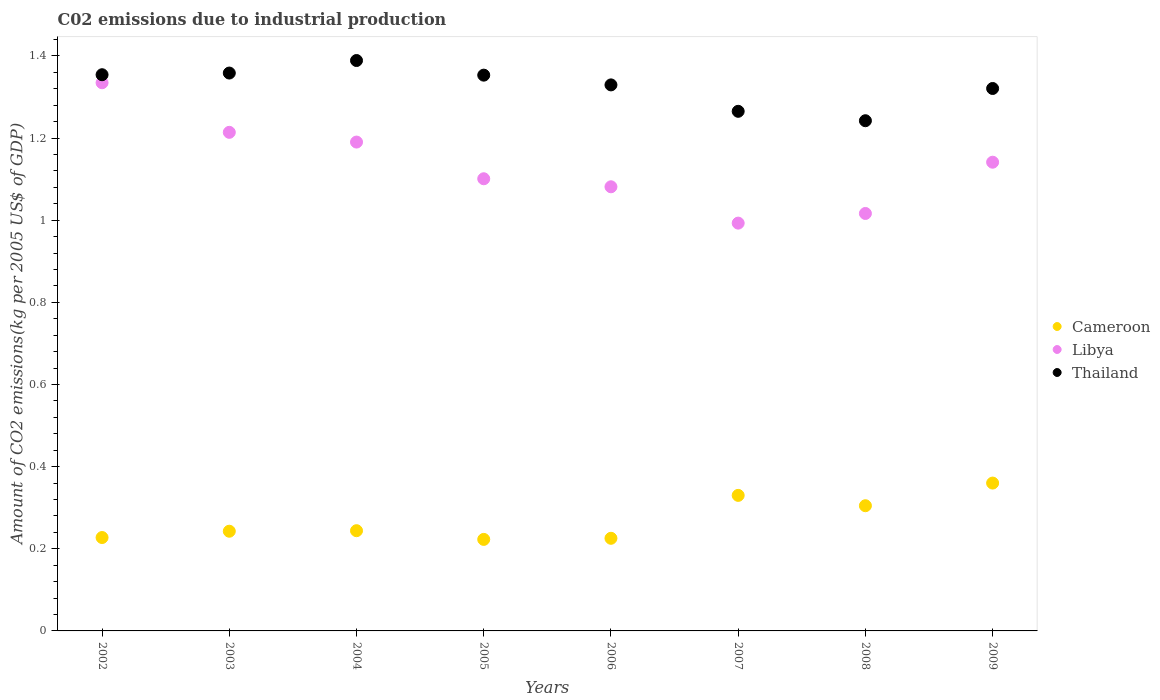How many different coloured dotlines are there?
Your answer should be compact. 3. Is the number of dotlines equal to the number of legend labels?
Provide a succinct answer. Yes. What is the amount of CO2 emitted due to industrial production in Cameroon in 2006?
Make the answer very short. 0.23. Across all years, what is the maximum amount of CO2 emitted due to industrial production in Thailand?
Offer a terse response. 1.39. Across all years, what is the minimum amount of CO2 emitted due to industrial production in Thailand?
Your answer should be very brief. 1.24. In which year was the amount of CO2 emitted due to industrial production in Libya maximum?
Keep it short and to the point. 2002. In which year was the amount of CO2 emitted due to industrial production in Libya minimum?
Your response must be concise. 2007. What is the total amount of CO2 emitted due to industrial production in Libya in the graph?
Your answer should be compact. 9.07. What is the difference between the amount of CO2 emitted due to industrial production in Libya in 2005 and that in 2006?
Your answer should be compact. 0.02. What is the difference between the amount of CO2 emitted due to industrial production in Libya in 2004 and the amount of CO2 emitted due to industrial production in Cameroon in 2003?
Give a very brief answer. 0.95. What is the average amount of CO2 emitted due to industrial production in Libya per year?
Provide a succinct answer. 1.13. In the year 2007, what is the difference between the amount of CO2 emitted due to industrial production in Libya and amount of CO2 emitted due to industrial production in Cameroon?
Your response must be concise. 0.66. What is the ratio of the amount of CO2 emitted due to industrial production in Libya in 2008 to that in 2009?
Keep it short and to the point. 0.89. What is the difference between the highest and the second highest amount of CO2 emitted due to industrial production in Thailand?
Your answer should be very brief. 0.03. What is the difference between the highest and the lowest amount of CO2 emitted due to industrial production in Thailand?
Make the answer very short. 0.15. In how many years, is the amount of CO2 emitted due to industrial production in Thailand greater than the average amount of CO2 emitted due to industrial production in Thailand taken over all years?
Make the answer very short. 5. Does the amount of CO2 emitted due to industrial production in Libya monotonically increase over the years?
Provide a succinct answer. No. Is the amount of CO2 emitted due to industrial production in Libya strictly less than the amount of CO2 emitted due to industrial production in Thailand over the years?
Provide a succinct answer. Yes. How many years are there in the graph?
Ensure brevity in your answer.  8. What is the difference between two consecutive major ticks on the Y-axis?
Give a very brief answer. 0.2. Does the graph contain grids?
Ensure brevity in your answer.  No. Where does the legend appear in the graph?
Provide a short and direct response. Center right. How are the legend labels stacked?
Offer a terse response. Vertical. What is the title of the graph?
Offer a very short reply. C02 emissions due to industrial production. What is the label or title of the Y-axis?
Your answer should be compact. Amount of CO2 emissions(kg per 2005 US$ of GDP). What is the Amount of CO2 emissions(kg per 2005 US$ of GDP) of Cameroon in 2002?
Give a very brief answer. 0.23. What is the Amount of CO2 emissions(kg per 2005 US$ of GDP) of Libya in 2002?
Offer a terse response. 1.33. What is the Amount of CO2 emissions(kg per 2005 US$ of GDP) in Thailand in 2002?
Your answer should be compact. 1.35. What is the Amount of CO2 emissions(kg per 2005 US$ of GDP) in Cameroon in 2003?
Provide a short and direct response. 0.24. What is the Amount of CO2 emissions(kg per 2005 US$ of GDP) of Libya in 2003?
Provide a short and direct response. 1.21. What is the Amount of CO2 emissions(kg per 2005 US$ of GDP) of Thailand in 2003?
Offer a very short reply. 1.36. What is the Amount of CO2 emissions(kg per 2005 US$ of GDP) in Cameroon in 2004?
Offer a very short reply. 0.24. What is the Amount of CO2 emissions(kg per 2005 US$ of GDP) of Libya in 2004?
Offer a terse response. 1.19. What is the Amount of CO2 emissions(kg per 2005 US$ of GDP) in Thailand in 2004?
Your response must be concise. 1.39. What is the Amount of CO2 emissions(kg per 2005 US$ of GDP) in Cameroon in 2005?
Offer a very short reply. 0.22. What is the Amount of CO2 emissions(kg per 2005 US$ of GDP) of Libya in 2005?
Keep it short and to the point. 1.1. What is the Amount of CO2 emissions(kg per 2005 US$ of GDP) of Thailand in 2005?
Your answer should be compact. 1.35. What is the Amount of CO2 emissions(kg per 2005 US$ of GDP) of Cameroon in 2006?
Ensure brevity in your answer.  0.23. What is the Amount of CO2 emissions(kg per 2005 US$ of GDP) in Libya in 2006?
Your answer should be very brief. 1.08. What is the Amount of CO2 emissions(kg per 2005 US$ of GDP) in Thailand in 2006?
Give a very brief answer. 1.33. What is the Amount of CO2 emissions(kg per 2005 US$ of GDP) of Cameroon in 2007?
Ensure brevity in your answer.  0.33. What is the Amount of CO2 emissions(kg per 2005 US$ of GDP) in Libya in 2007?
Offer a terse response. 0.99. What is the Amount of CO2 emissions(kg per 2005 US$ of GDP) in Thailand in 2007?
Ensure brevity in your answer.  1.27. What is the Amount of CO2 emissions(kg per 2005 US$ of GDP) of Cameroon in 2008?
Provide a succinct answer. 0.3. What is the Amount of CO2 emissions(kg per 2005 US$ of GDP) of Libya in 2008?
Offer a very short reply. 1.02. What is the Amount of CO2 emissions(kg per 2005 US$ of GDP) in Thailand in 2008?
Offer a terse response. 1.24. What is the Amount of CO2 emissions(kg per 2005 US$ of GDP) of Cameroon in 2009?
Your answer should be compact. 0.36. What is the Amount of CO2 emissions(kg per 2005 US$ of GDP) in Libya in 2009?
Make the answer very short. 1.14. What is the Amount of CO2 emissions(kg per 2005 US$ of GDP) in Thailand in 2009?
Make the answer very short. 1.32. Across all years, what is the maximum Amount of CO2 emissions(kg per 2005 US$ of GDP) in Cameroon?
Your response must be concise. 0.36. Across all years, what is the maximum Amount of CO2 emissions(kg per 2005 US$ of GDP) in Libya?
Your answer should be compact. 1.33. Across all years, what is the maximum Amount of CO2 emissions(kg per 2005 US$ of GDP) in Thailand?
Provide a succinct answer. 1.39. Across all years, what is the minimum Amount of CO2 emissions(kg per 2005 US$ of GDP) in Cameroon?
Provide a short and direct response. 0.22. Across all years, what is the minimum Amount of CO2 emissions(kg per 2005 US$ of GDP) of Libya?
Your response must be concise. 0.99. Across all years, what is the minimum Amount of CO2 emissions(kg per 2005 US$ of GDP) of Thailand?
Give a very brief answer. 1.24. What is the total Amount of CO2 emissions(kg per 2005 US$ of GDP) in Cameroon in the graph?
Your response must be concise. 2.16. What is the total Amount of CO2 emissions(kg per 2005 US$ of GDP) of Libya in the graph?
Your response must be concise. 9.07. What is the total Amount of CO2 emissions(kg per 2005 US$ of GDP) of Thailand in the graph?
Your answer should be very brief. 10.61. What is the difference between the Amount of CO2 emissions(kg per 2005 US$ of GDP) of Cameroon in 2002 and that in 2003?
Offer a very short reply. -0.02. What is the difference between the Amount of CO2 emissions(kg per 2005 US$ of GDP) of Libya in 2002 and that in 2003?
Ensure brevity in your answer.  0.12. What is the difference between the Amount of CO2 emissions(kg per 2005 US$ of GDP) in Thailand in 2002 and that in 2003?
Make the answer very short. -0. What is the difference between the Amount of CO2 emissions(kg per 2005 US$ of GDP) of Cameroon in 2002 and that in 2004?
Make the answer very short. -0.02. What is the difference between the Amount of CO2 emissions(kg per 2005 US$ of GDP) of Libya in 2002 and that in 2004?
Offer a very short reply. 0.14. What is the difference between the Amount of CO2 emissions(kg per 2005 US$ of GDP) in Thailand in 2002 and that in 2004?
Offer a very short reply. -0.03. What is the difference between the Amount of CO2 emissions(kg per 2005 US$ of GDP) of Cameroon in 2002 and that in 2005?
Ensure brevity in your answer.  0. What is the difference between the Amount of CO2 emissions(kg per 2005 US$ of GDP) in Libya in 2002 and that in 2005?
Keep it short and to the point. 0.23. What is the difference between the Amount of CO2 emissions(kg per 2005 US$ of GDP) of Thailand in 2002 and that in 2005?
Your answer should be compact. 0. What is the difference between the Amount of CO2 emissions(kg per 2005 US$ of GDP) in Cameroon in 2002 and that in 2006?
Offer a very short reply. 0. What is the difference between the Amount of CO2 emissions(kg per 2005 US$ of GDP) in Libya in 2002 and that in 2006?
Make the answer very short. 0.25. What is the difference between the Amount of CO2 emissions(kg per 2005 US$ of GDP) of Thailand in 2002 and that in 2006?
Provide a succinct answer. 0.02. What is the difference between the Amount of CO2 emissions(kg per 2005 US$ of GDP) in Cameroon in 2002 and that in 2007?
Your answer should be compact. -0.1. What is the difference between the Amount of CO2 emissions(kg per 2005 US$ of GDP) in Libya in 2002 and that in 2007?
Ensure brevity in your answer.  0.34. What is the difference between the Amount of CO2 emissions(kg per 2005 US$ of GDP) in Thailand in 2002 and that in 2007?
Your response must be concise. 0.09. What is the difference between the Amount of CO2 emissions(kg per 2005 US$ of GDP) of Cameroon in 2002 and that in 2008?
Provide a succinct answer. -0.08. What is the difference between the Amount of CO2 emissions(kg per 2005 US$ of GDP) in Libya in 2002 and that in 2008?
Give a very brief answer. 0.32. What is the difference between the Amount of CO2 emissions(kg per 2005 US$ of GDP) of Thailand in 2002 and that in 2008?
Keep it short and to the point. 0.11. What is the difference between the Amount of CO2 emissions(kg per 2005 US$ of GDP) in Cameroon in 2002 and that in 2009?
Provide a short and direct response. -0.13. What is the difference between the Amount of CO2 emissions(kg per 2005 US$ of GDP) of Libya in 2002 and that in 2009?
Provide a succinct answer. 0.19. What is the difference between the Amount of CO2 emissions(kg per 2005 US$ of GDP) of Thailand in 2002 and that in 2009?
Your answer should be very brief. 0.03. What is the difference between the Amount of CO2 emissions(kg per 2005 US$ of GDP) of Cameroon in 2003 and that in 2004?
Keep it short and to the point. -0. What is the difference between the Amount of CO2 emissions(kg per 2005 US$ of GDP) of Libya in 2003 and that in 2004?
Offer a terse response. 0.02. What is the difference between the Amount of CO2 emissions(kg per 2005 US$ of GDP) in Thailand in 2003 and that in 2004?
Provide a succinct answer. -0.03. What is the difference between the Amount of CO2 emissions(kg per 2005 US$ of GDP) of Cameroon in 2003 and that in 2005?
Keep it short and to the point. 0.02. What is the difference between the Amount of CO2 emissions(kg per 2005 US$ of GDP) in Libya in 2003 and that in 2005?
Your answer should be compact. 0.11. What is the difference between the Amount of CO2 emissions(kg per 2005 US$ of GDP) in Thailand in 2003 and that in 2005?
Your answer should be compact. 0.01. What is the difference between the Amount of CO2 emissions(kg per 2005 US$ of GDP) in Cameroon in 2003 and that in 2006?
Your answer should be very brief. 0.02. What is the difference between the Amount of CO2 emissions(kg per 2005 US$ of GDP) in Libya in 2003 and that in 2006?
Your answer should be compact. 0.13. What is the difference between the Amount of CO2 emissions(kg per 2005 US$ of GDP) of Thailand in 2003 and that in 2006?
Ensure brevity in your answer.  0.03. What is the difference between the Amount of CO2 emissions(kg per 2005 US$ of GDP) in Cameroon in 2003 and that in 2007?
Your answer should be compact. -0.09. What is the difference between the Amount of CO2 emissions(kg per 2005 US$ of GDP) of Libya in 2003 and that in 2007?
Your answer should be compact. 0.22. What is the difference between the Amount of CO2 emissions(kg per 2005 US$ of GDP) of Thailand in 2003 and that in 2007?
Provide a succinct answer. 0.09. What is the difference between the Amount of CO2 emissions(kg per 2005 US$ of GDP) of Cameroon in 2003 and that in 2008?
Offer a terse response. -0.06. What is the difference between the Amount of CO2 emissions(kg per 2005 US$ of GDP) in Libya in 2003 and that in 2008?
Ensure brevity in your answer.  0.2. What is the difference between the Amount of CO2 emissions(kg per 2005 US$ of GDP) of Thailand in 2003 and that in 2008?
Your answer should be very brief. 0.12. What is the difference between the Amount of CO2 emissions(kg per 2005 US$ of GDP) in Cameroon in 2003 and that in 2009?
Make the answer very short. -0.12. What is the difference between the Amount of CO2 emissions(kg per 2005 US$ of GDP) in Libya in 2003 and that in 2009?
Keep it short and to the point. 0.07. What is the difference between the Amount of CO2 emissions(kg per 2005 US$ of GDP) in Thailand in 2003 and that in 2009?
Provide a succinct answer. 0.04. What is the difference between the Amount of CO2 emissions(kg per 2005 US$ of GDP) in Cameroon in 2004 and that in 2005?
Your answer should be compact. 0.02. What is the difference between the Amount of CO2 emissions(kg per 2005 US$ of GDP) in Libya in 2004 and that in 2005?
Offer a very short reply. 0.09. What is the difference between the Amount of CO2 emissions(kg per 2005 US$ of GDP) in Thailand in 2004 and that in 2005?
Your answer should be compact. 0.04. What is the difference between the Amount of CO2 emissions(kg per 2005 US$ of GDP) in Cameroon in 2004 and that in 2006?
Make the answer very short. 0.02. What is the difference between the Amount of CO2 emissions(kg per 2005 US$ of GDP) of Libya in 2004 and that in 2006?
Your response must be concise. 0.11. What is the difference between the Amount of CO2 emissions(kg per 2005 US$ of GDP) in Thailand in 2004 and that in 2006?
Your answer should be very brief. 0.06. What is the difference between the Amount of CO2 emissions(kg per 2005 US$ of GDP) in Cameroon in 2004 and that in 2007?
Your response must be concise. -0.09. What is the difference between the Amount of CO2 emissions(kg per 2005 US$ of GDP) of Libya in 2004 and that in 2007?
Offer a terse response. 0.2. What is the difference between the Amount of CO2 emissions(kg per 2005 US$ of GDP) in Thailand in 2004 and that in 2007?
Your answer should be very brief. 0.12. What is the difference between the Amount of CO2 emissions(kg per 2005 US$ of GDP) of Cameroon in 2004 and that in 2008?
Make the answer very short. -0.06. What is the difference between the Amount of CO2 emissions(kg per 2005 US$ of GDP) of Libya in 2004 and that in 2008?
Provide a succinct answer. 0.17. What is the difference between the Amount of CO2 emissions(kg per 2005 US$ of GDP) of Thailand in 2004 and that in 2008?
Your answer should be compact. 0.15. What is the difference between the Amount of CO2 emissions(kg per 2005 US$ of GDP) of Cameroon in 2004 and that in 2009?
Make the answer very short. -0.12. What is the difference between the Amount of CO2 emissions(kg per 2005 US$ of GDP) in Libya in 2004 and that in 2009?
Provide a succinct answer. 0.05. What is the difference between the Amount of CO2 emissions(kg per 2005 US$ of GDP) in Thailand in 2004 and that in 2009?
Provide a succinct answer. 0.07. What is the difference between the Amount of CO2 emissions(kg per 2005 US$ of GDP) in Cameroon in 2005 and that in 2006?
Make the answer very short. -0. What is the difference between the Amount of CO2 emissions(kg per 2005 US$ of GDP) of Libya in 2005 and that in 2006?
Offer a very short reply. 0.02. What is the difference between the Amount of CO2 emissions(kg per 2005 US$ of GDP) of Thailand in 2005 and that in 2006?
Give a very brief answer. 0.02. What is the difference between the Amount of CO2 emissions(kg per 2005 US$ of GDP) of Cameroon in 2005 and that in 2007?
Ensure brevity in your answer.  -0.11. What is the difference between the Amount of CO2 emissions(kg per 2005 US$ of GDP) in Libya in 2005 and that in 2007?
Keep it short and to the point. 0.11. What is the difference between the Amount of CO2 emissions(kg per 2005 US$ of GDP) in Thailand in 2005 and that in 2007?
Make the answer very short. 0.09. What is the difference between the Amount of CO2 emissions(kg per 2005 US$ of GDP) of Cameroon in 2005 and that in 2008?
Your response must be concise. -0.08. What is the difference between the Amount of CO2 emissions(kg per 2005 US$ of GDP) of Libya in 2005 and that in 2008?
Your answer should be compact. 0.08. What is the difference between the Amount of CO2 emissions(kg per 2005 US$ of GDP) of Thailand in 2005 and that in 2008?
Give a very brief answer. 0.11. What is the difference between the Amount of CO2 emissions(kg per 2005 US$ of GDP) of Cameroon in 2005 and that in 2009?
Your answer should be very brief. -0.14. What is the difference between the Amount of CO2 emissions(kg per 2005 US$ of GDP) in Libya in 2005 and that in 2009?
Keep it short and to the point. -0.04. What is the difference between the Amount of CO2 emissions(kg per 2005 US$ of GDP) of Thailand in 2005 and that in 2009?
Provide a short and direct response. 0.03. What is the difference between the Amount of CO2 emissions(kg per 2005 US$ of GDP) of Cameroon in 2006 and that in 2007?
Ensure brevity in your answer.  -0.1. What is the difference between the Amount of CO2 emissions(kg per 2005 US$ of GDP) in Libya in 2006 and that in 2007?
Your answer should be compact. 0.09. What is the difference between the Amount of CO2 emissions(kg per 2005 US$ of GDP) in Thailand in 2006 and that in 2007?
Offer a terse response. 0.06. What is the difference between the Amount of CO2 emissions(kg per 2005 US$ of GDP) in Cameroon in 2006 and that in 2008?
Your answer should be compact. -0.08. What is the difference between the Amount of CO2 emissions(kg per 2005 US$ of GDP) in Libya in 2006 and that in 2008?
Keep it short and to the point. 0.07. What is the difference between the Amount of CO2 emissions(kg per 2005 US$ of GDP) in Thailand in 2006 and that in 2008?
Provide a succinct answer. 0.09. What is the difference between the Amount of CO2 emissions(kg per 2005 US$ of GDP) of Cameroon in 2006 and that in 2009?
Your response must be concise. -0.13. What is the difference between the Amount of CO2 emissions(kg per 2005 US$ of GDP) in Libya in 2006 and that in 2009?
Offer a very short reply. -0.06. What is the difference between the Amount of CO2 emissions(kg per 2005 US$ of GDP) of Thailand in 2006 and that in 2009?
Give a very brief answer. 0.01. What is the difference between the Amount of CO2 emissions(kg per 2005 US$ of GDP) of Cameroon in 2007 and that in 2008?
Your answer should be compact. 0.03. What is the difference between the Amount of CO2 emissions(kg per 2005 US$ of GDP) of Libya in 2007 and that in 2008?
Offer a terse response. -0.02. What is the difference between the Amount of CO2 emissions(kg per 2005 US$ of GDP) of Thailand in 2007 and that in 2008?
Offer a terse response. 0.02. What is the difference between the Amount of CO2 emissions(kg per 2005 US$ of GDP) of Cameroon in 2007 and that in 2009?
Provide a short and direct response. -0.03. What is the difference between the Amount of CO2 emissions(kg per 2005 US$ of GDP) of Libya in 2007 and that in 2009?
Your response must be concise. -0.15. What is the difference between the Amount of CO2 emissions(kg per 2005 US$ of GDP) in Thailand in 2007 and that in 2009?
Your response must be concise. -0.06. What is the difference between the Amount of CO2 emissions(kg per 2005 US$ of GDP) in Cameroon in 2008 and that in 2009?
Ensure brevity in your answer.  -0.06. What is the difference between the Amount of CO2 emissions(kg per 2005 US$ of GDP) in Libya in 2008 and that in 2009?
Ensure brevity in your answer.  -0.12. What is the difference between the Amount of CO2 emissions(kg per 2005 US$ of GDP) in Thailand in 2008 and that in 2009?
Your answer should be compact. -0.08. What is the difference between the Amount of CO2 emissions(kg per 2005 US$ of GDP) in Cameroon in 2002 and the Amount of CO2 emissions(kg per 2005 US$ of GDP) in Libya in 2003?
Offer a very short reply. -0.99. What is the difference between the Amount of CO2 emissions(kg per 2005 US$ of GDP) of Cameroon in 2002 and the Amount of CO2 emissions(kg per 2005 US$ of GDP) of Thailand in 2003?
Keep it short and to the point. -1.13. What is the difference between the Amount of CO2 emissions(kg per 2005 US$ of GDP) of Libya in 2002 and the Amount of CO2 emissions(kg per 2005 US$ of GDP) of Thailand in 2003?
Provide a short and direct response. -0.02. What is the difference between the Amount of CO2 emissions(kg per 2005 US$ of GDP) in Cameroon in 2002 and the Amount of CO2 emissions(kg per 2005 US$ of GDP) in Libya in 2004?
Offer a very short reply. -0.96. What is the difference between the Amount of CO2 emissions(kg per 2005 US$ of GDP) of Cameroon in 2002 and the Amount of CO2 emissions(kg per 2005 US$ of GDP) of Thailand in 2004?
Provide a succinct answer. -1.16. What is the difference between the Amount of CO2 emissions(kg per 2005 US$ of GDP) of Libya in 2002 and the Amount of CO2 emissions(kg per 2005 US$ of GDP) of Thailand in 2004?
Your answer should be compact. -0.05. What is the difference between the Amount of CO2 emissions(kg per 2005 US$ of GDP) of Cameroon in 2002 and the Amount of CO2 emissions(kg per 2005 US$ of GDP) of Libya in 2005?
Offer a terse response. -0.87. What is the difference between the Amount of CO2 emissions(kg per 2005 US$ of GDP) in Cameroon in 2002 and the Amount of CO2 emissions(kg per 2005 US$ of GDP) in Thailand in 2005?
Offer a very short reply. -1.13. What is the difference between the Amount of CO2 emissions(kg per 2005 US$ of GDP) in Libya in 2002 and the Amount of CO2 emissions(kg per 2005 US$ of GDP) in Thailand in 2005?
Provide a short and direct response. -0.02. What is the difference between the Amount of CO2 emissions(kg per 2005 US$ of GDP) of Cameroon in 2002 and the Amount of CO2 emissions(kg per 2005 US$ of GDP) of Libya in 2006?
Your response must be concise. -0.85. What is the difference between the Amount of CO2 emissions(kg per 2005 US$ of GDP) of Cameroon in 2002 and the Amount of CO2 emissions(kg per 2005 US$ of GDP) of Thailand in 2006?
Your answer should be very brief. -1.1. What is the difference between the Amount of CO2 emissions(kg per 2005 US$ of GDP) of Libya in 2002 and the Amount of CO2 emissions(kg per 2005 US$ of GDP) of Thailand in 2006?
Offer a very short reply. 0.01. What is the difference between the Amount of CO2 emissions(kg per 2005 US$ of GDP) in Cameroon in 2002 and the Amount of CO2 emissions(kg per 2005 US$ of GDP) in Libya in 2007?
Ensure brevity in your answer.  -0.77. What is the difference between the Amount of CO2 emissions(kg per 2005 US$ of GDP) in Cameroon in 2002 and the Amount of CO2 emissions(kg per 2005 US$ of GDP) in Thailand in 2007?
Provide a short and direct response. -1.04. What is the difference between the Amount of CO2 emissions(kg per 2005 US$ of GDP) of Libya in 2002 and the Amount of CO2 emissions(kg per 2005 US$ of GDP) of Thailand in 2007?
Your response must be concise. 0.07. What is the difference between the Amount of CO2 emissions(kg per 2005 US$ of GDP) of Cameroon in 2002 and the Amount of CO2 emissions(kg per 2005 US$ of GDP) of Libya in 2008?
Provide a short and direct response. -0.79. What is the difference between the Amount of CO2 emissions(kg per 2005 US$ of GDP) of Cameroon in 2002 and the Amount of CO2 emissions(kg per 2005 US$ of GDP) of Thailand in 2008?
Keep it short and to the point. -1.01. What is the difference between the Amount of CO2 emissions(kg per 2005 US$ of GDP) of Libya in 2002 and the Amount of CO2 emissions(kg per 2005 US$ of GDP) of Thailand in 2008?
Offer a very short reply. 0.09. What is the difference between the Amount of CO2 emissions(kg per 2005 US$ of GDP) in Cameroon in 2002 and the Amount of CO2 emissions(kg per 2005 US$ of GDP) in Libya in 2009?
Your answer should be compact. -0.91. What is the difference between the Amount of CO2 emissions(kg per 2005 US$ of GDP) in Cameroon in 2002 and the Amount of CO2 emissions(kg per 2005 US$ of GDP) in Thailand in 2009?
Ensure brevity in your answer.  -1.09. What is the difference between the Amount of CO2 emissions(kg per 2005 US$ of GDP) in Libya in 2002 and the Amount of CO2 emissions(kg per 2005 US$ of GDP) in Thailand in 2009?
Your answer should be compact. 0.01. What is the difference between the Amount of CO2 emissions(kg per 2005 US$ of GDP) in Cameroon in 2003 and the Amount of CO2 emissions(kg per 2005 US$ of GDP) in Libya in 2004?
Keep it short and to the point. -0.95. What is the difference between the Amount of CO2 emissions(kg per 2005 US$ of GDP) of Cameroon in 2003 and the Amount of CO2 emissions(kg per 2005 US$ of GDP) of Thailand in 2004?
Offer a terse response. -1.15. What is the difference between the Amount of CO2 emissions(kg per 2005 US$ of GDP) of Libya in 2003 and the Amount of CO2 emissions(kg per 2005 US$ of GDP) of Thailand in 2004?
Your answer should be very brief. -0.17. What is the difference between the Amount of CO2 emissions(kg per 2005 US$ of GDP) in Cameroon in 2003 and the Amount of CO2 emissions(kg per 2005 US$ of GDP) in Libya in 2005?
Your answer should be very brief. -0.86. What is the difference between the Amount of CO2 emissions(kg per 2005 US$ of GDP) of Cameroon in 2003 and the Amount of CO2 emissions(kg per 2005 US$ of GDP) of Thailand in 2005?
Provide a short and direct response. -1.11. What is the difference between the Amount of CO2 emissions(kg per 2005 US$ of GDP) of Libya in 2003 and the Amount of CO2 emissions(kg per 2005 US$ of GDP) of Thailand in 2005?
Your answer should be very brief. -0.14. What is the difference between the Amount of CO2 emissions(kg per 2005 US$ of GDP) of Cameroon in 2003 and the Amount of CO2 emissions(kg per 2005 US$ of GDP) of Libya in 2006?
Make the answer very short. -0.84. What is the difference between the Amount of CO2 emissions(kg per 2005 US$ of GDP) in Cameroon in 2003 and the Amount of CO2 emissions(kg per 2005 US$ of GDP) in Thailand in 2006?
Make the answer very short. -1.09. What is the difference between the Amount of CO2 emissions(kg per 2005 US$ of GDP) in Libya in 2003 and the Amount of CO2 emissions(kg per 2005 US$ of GDP) in Thailand in 2006?
Your answer should be very brief. -0.12. What is the difference between the Amount of CO2 emissions(kg per 2005 US$ of GDP) in Cameroon in 2003 and the Amount of CO2 emissions(kg per 2005 US$ of GDP) in Libya in 2007?
Offer a terse response. -0.75. What is the difference between the Amount of CO2 emissions(kg per 2005 US$ of GDP) of Cameroon in 2003 and the Amount of CO2 emissions(kg per 2005 US$ of GDP) of Thailand in 2007?
Ensure brevity in your answer.  -1.02. What is the difference between the Amount of CO2 emissions(kg per 2005 US$ of GDP) in Libya in 2003 and the Amount of CO2 emissions(kg per 2005 US$ of GDP) in Thailand in 2007?
Provide a succinct answer. -0.05. What is the difference between the Amount of CO2 emissions(kg per 2005 US$ of GDP) in Cameroon in 2003 and the Amount of CO2 emissions(kg per 2005 US$ of GDP) in Libya in 2008?
Make the answer very short. -0.77. What is the difference between the Amount of CO2 emissions(kg per 2005 US$ of GDP) in Cameroon in 2003 and the Amount of CO2 emissions(kg per 2005 US$ of GDP) in Thailand in 2008?
Provide a short and direct response. -1. What is the difference between the Amount of CO2 emissions(kg per 2005 US$ of GDP) of Libya in 2003 and the Amount of CO2 emissions(kg per 2005 US$ of GDP) of Thailand in 2008?
Make the answer very short. -0.03. What is the difference between the Amount of CO2 emissions(kg per 2005 US$ of GDP) of Cameroon in 2003 and the Amount of CO2 emissions(kg per 2005 US$ of GDP) of Libya in 2009?
Offer a terse response. -0.9. What is the difference between the Amount of CO2 emissions(kg per 2005 US$ of GDP) in Cameroon in 2003 and the Amount of CO2 emissions(kg per 2005 US$ of GDP) in Thailand in 2009?
Your answer should be compact. -1.08. What is the difference between the Amount of CO2 emissions(kg per 2005 US$ of GDP) in Libya in 2003 and the Amount of CO2 emissions(kg per 2005 US$ of GDP) in Thailand in 2009?
Keep it short and to the point. -0.11. What is the difference between the Amount of CO2 emissions(kg per 2005 US$ of GDP) of Cameroon in 2004 and the Amount of CO2 emissions(kg per 2005 US$ of GDP) of Libya in 2005?
Your answer should be very brief. -0.86. What is the difference between the Amount of CO2 emissions(kg per 2005 US$ of GDP) of Cameroon in 2004 and the Amount of CO2 emissions(kg per 2005 US$ of GDP) of Thailand in 2005?
Offer a very short reply. -1.11. What is the difference between the Amount of CO2 emissions(kg per 2005 US$ of GDP) in Libya in 2004 and the Amount of CO2 emissions(kg per 2005 US$ of GDP) in Thailand in 2005?
Ensure brevity in your answer.  -0.16. What is the difference between the Amount of CO2 emissions(kg per 2005 US$ of GDP) of Cameroon in 2004 and the Amount of CO2 emissions(kg per 2005 US$ of GDP) of Libya in 2006?
Your answer should be compact. -0.84. What is the difference between the Amount of CO2 emissions(kg per 2005 US$ of GDP) of Cameroon in 2004 and the Amount of CO2 emissions(kg per 2005 US$ of GDP) of Thailand in 2006?
Your answer should be very brief. -1.09. What is the difference between the Amount of CO2 emissions(kg per 2005 US$ of GDP) of Libya in 2004 and the Amount of CO2 emissions(kg per 2005 US$ of GDP) of Thailand in 2006?
Give a very brief answer. -0.14. What is the difference between the Amount of CO2 emissions(kg per 2005 US$ of GDP) in Cameroon in 2004 and the Amount of CO2 emissions(kg per 2005 US$ of GDP) in Libya in 2007?
Your response must be concise. -0.75. What is the difference between the Amount of CO2 emissions(kg per 2005 US$ of GDP) of Cameroon in 2004 and the Amount of CO2 emissions(kg per 2005 US$ of GDP) of Thailand in 2007?
Keep it short and to the point. -1.02. What is the difference between the Amount of CO2 emissions(kg per 2005 US$ of GDP) in Libya in 2004 and the Amount of CO2 emissions(kg per 2005 US$ of GDP) in Thailand in 2007?
Your answer should be very brief. -0.07. What is the difference between the Amount of CO2 emissions(kg per 2005 US$ of GDP) of Cameroon in 2004 and the Amount of CO2 emissions(kg per 2005 US$ of GDP) of Libya in 2008?
Offer a very short reply. -0.77. What is the difference between the Amount of CO2 emissions(kg per 2005 US$ of GDP) of Cameroon in 2004 and the Amount of CO2 emissions(kg per 2005 US$ of GDP) of Thailand in 2008?
Provide a succinct answer. -1. What is the difference between the Amount of CO2 emissions(kg per 2005 US$ of GDP) in Libya in 2004 and the Amount of CO2 emissions(kg per 2005 US$ of GDP) in Thailand in 2008?
Give a very brief answer. -0.05. What is the difference between the Amount of CO2 emissions(kg per 2005 US$ of GDP) in Cameroon in 2004 and the Amount of CO2 emissions(kg per 2005 US$ of GDP) in Libya in 2009?
Your answer should be very brief. -0.9. What is the difference between the Amount of CO2 emissions(kg per 2005 US$ of GDP) of Cameroon in 2004 and the Amount of CO2 emissions(kg per 2005 US$ of GDP) of Thailand in 2009?
Provide a succinct answer. -1.08. What is the difference between the Amount of CO2 emissions(kg per 2005 US$ of GDP) in Libya in 2004 and the Amount of CO2 emissions(kg per 2005 US$ of GDP) in Thailand in 2009?
Offer a very short reply. -0.13. What is the difference between the Amount of CO2 emissions(kg per 2005 US$ of GDP) of Cameroon in 2005 and the Amount of CO2 emissions(kg per 2005 US$ of GDP) of Libya in 2006?
Give a very brief answer. -0.86. What is the difference between the Amount of CO2 emissions(kg per 2005 US$ of GDP) in Cameroon in 2005 and the Amount of CO2 emissions(kg per 2005 US$ of GDP) in Thailand in 2006?
Ensure brevity in your answer.  -1.11. What is the difference between the Amount of CO2 emissions(kg per 2005 US$ of GDP) of Libya in 2005 and the Amount of CO2 emissions(kg per 2005 US$ of GDP) of Thailand in 2006?
Offer a very short reply. -0.23. What is the difference between the Amount of CO2 emissions(kg per 2005 US$ of GDP) of Cameroon in 2005 and the Amount of CO2 emissions(kg per 2005 US$ of GDP) of Libya in 2007?
Give a very brief answer. -0.77. What is the difference between the Amount of CO2 emissions(kg per 2005 US$ of GDP) in Cameroon in 2005 and the Amount of CO2 emissions(kg per 2005 US$ of GDP) in Thailand in 2007?
Your answer should be compact. -1.04. What is the difference between the Amount of CO2 emissions(kg per 2005 US$ of GDP) in Libya in 2005 and the Amount of CO2 emissions(kg per 2005 US$ of GDP) in Thailand in 2007?
Make the answer very short. -0.16. What is the difference between the Amount of CO2 emissions(kg per 2005 US$ of GDP) of Cameroon in 2005 and the Amount of CO2 emissions(kg per 2005 US$ of GDP) of Libya in 2008?
Make the answer very short. -0.79. What is the difference between the Amount of CO2 emissions(kg per 2005 US$ of GDP) in Cameroon in 2005 and the Amount of CO2 emissions(kg per 2005 US$ of GDP) in Thailand in 2008?
Keep it short and to the point. -1.02. What is the difference between the Amount of CO2 emissions(kg per 2005 US$ of GDP) in Libya in 2005 and the Amount of CO2 emissions(kg per 2005 US$ of GDP) in Thailand in 2008?
Make the answer very short. -0.14. What is the difference between the Amount of CO2 emissions(kg per 2005 US$ of GDP) in Cameroon in 2005 and the Amount of CO2 emissions(kg per 2005 US$ of GDP) in Libya in 2009?
Your response must be concise. -0.92. What is the difference between the Amount of CO2 emissions(kg per 2005 US$ of GDP) of Cameroon in 2005 and the Amount of CO2 emissions(kg per 2005 US$ of GDP) of Thailand in 2009?
Give a very brief answer. -1.1. What is the difference between the Amount of CO2 emissions(kg per 2005 US$ of GDP) of Libya in 2005 and the Amount of CO2 emissions(kg per 2005 US$ of GDP) of Thailand in 2009?
Give a very brief answer. -0.22. What is the difference between the Amount of CO2 emissions(kg per 2005 US$ of GDP) in Cameroon in 2006 and the Amount of CO2 emissions(kg per 2005 US$ of GDP) in Libya in 2007?
Offer a terse response. -0.77. What is the difference between the Amount of CO2 emissions(kg per 2005 US$ of GDP) of Cameroon in 2006 and the Amount of CO2 emissions(kg per 2005 US$ of GDP) of Thailand in 2007?
Give a very brief answer. -1.04. What is the difference between the Amount of CO2 emissions(kg per 2005 US$ of GDP) of Libya in 2006 and the Amount of CO2 emissions(kg per 2005 US$ of GDP) of Thailand in 2007?
Your answer should be compact. -0.18. What is the difference between the Amount of CO2 emissions(kg per 2005 US$ of GDP) of Cameroon in 2006 and the Amount of CO2 emissions(kg per 2005 US$ of GDP) of Libya in 2008?
Ensure brevity in your answer.  -0.79. What is the difference between the Amount of CO2 emissions(kg per 2005 US$ of GDP) in Cameroon in 2006 and the Amount of CO2 emissions(kg per 2005 US$ of GDP) in Thailand in 2008?
Provide a short and direct response. -1.02. What is the difference between the Amount of CO2 emissions(kg per 2005 US$ of GDP) of Libya in 2006 and the Amount of CO2 emissions(kg per 2005 US$ of GDP) of Thailand in 2008?
Provide a short and direct response. -0.16. What is the difference between the Amount of CO2 emissions(kg per 2005 US$ of GDP) in Cameroon in 2006 and the Amount of CO2 emissions(kg per 2005 US$ of GDP) in Libya in 2009?
Keep it short and to the point. -0.92. What is the difference between the Amount of CO2 emissions(kg per 2005 US$ of GDP) in Cameroon in 2006 and the Amount of CO2 emissions(kg per 2005 US$ of GDP) in Thailand in 2009?
Your response must be concise. -1.1. What is the difference between the Amount of CO2 emissions(kg per 2005 US$ of GDP) of Libya in 2006 and the Amount of CO2 emissions(kg per 2005 US$ of GDP) of Thailand in 2009?
Make the answer very short. -0.24. What is the difference between the Amount of CO2 emissions(kg per 2005 US$ of GDP) of Cameroon in 2007 and the Amount of CO2 emissions(kg per 2005 US$ of GDP) of Libya in 2008?
Offer a terse response. -0.69. What is the difference between the Amount of CO2 emissions(kg per 2005 US$ of GDP) in Cameroon in 2007 and the Amount of CO2 emissions(kg per 2005 US$ of GDP) in Thailand in 2008?
Offer a very short reply. -0.91. What is the difference between the Amount of CO2 emissions(kg per 2005 US$ of GDP) in Libya in 2007 and the Amount of CO2 emissions(kg per 2005 US$ of GDP) in Thailand in 2008?
Keep it short and to the point. -0.25. What is the difference between the Amount of CO2 emissions(kg per 2005 US$ of GDP) in Cameroon in 2007 and the Amount of CO2 emissions(kg per 2005 US$ of GDP) in Libya in 2009?
Provide a short and direct response. -0.81. What is the difference between the Amount of CO2 emissions(kg per 2005 US$ of GDP) in Cameroon in 2007 and the Amount of CO2 emissions(kg per 2005 US$ of GDP) in Thailand in 2009?
Provide a succinct answer. -0.99. What is the difference between the Amount of CO2 emissions(kg per 2005 US$ of GDP) of Libya in 2007 and the Amount of CO2 emissions(kg per 2005 US$ of GDP) of Thailand in 2009?
Give a very brief answer. -0.33. What is the difference between the Amount of CO2 emissions(kg per 2005 US$ of GDP) in Cameroon in 2008 and the Amount of CO2 emissions(kg per 2005 US$ of GDP) in Libya in 2009?
Ensure brevity in your answer.  -0.84. What is the difference between the Amount of CO2 emissions(kg per 2005 US$ of GDP) in Cameroon in 2008 and the Amount of CO2 emissions(kg per 2005 US$ of GDP) in Thailand in 2009?
Make the answer very short. -1.02. What is the difference between the Amount of CO2 emissions(kg per 2005 US$ of GDP) of Libya in 2008 and the Amount of CO2 emissions(kg per 2005 US$ of GDP) of Thailand in 2009?
Your response must be concise. -0.3. What is the average Amount of CO2 emissions(kg per 2005 US$ of GDP) in Cameroon per year?
Ensure brevity in your answer.  0.27. What is the average Amount of CO2 emissions(kg per 2005 US$ of GDP) of Libya per year?
Your answer should be compact. 1.13. What is the average Amount of CO2 emissions(kg per 2005 US$ of GDP) in Thailand per year?
Give a very brief answer. 1.33. In the year 2002, what is the difference between the Amount of CO2 emissions(kg per 2005 US$ of GDP) in Cameroon and Amount of CO2 emissions(kg per 2005 US$ of GDP) in Libya?
Your response must be concise. -1.11. In the year 2002, what is the difference between the Amount of CO2 emissions(kg per 2005 US$ of GDP) of Cameroon and Amount of CO2 emissions(kg per 2005 US$ of GDP) of Thailand?
Your response must be concise. -1.13. In the year 2002, what is the difference between the Amount of CO2 emissions(kg per 2005 US$ of GDP) in Libya and Amount of CO2 emissions(kg per 2005 US$ of GDP) in Thailand?
Offer a very short reply. -0.02. In the year 2003, what is the difference between the Amount of CO2 emissions(kg per 2005 US$ of GDP) of Cameroon and Amount of CO2 emissions(kg per 2005 US$ of GDP) of Libya?
Give a very brief answer. -0.97. In the year 2003, what is the difference between the Amount of CO2 emissions(kg per 2005 US$ of GDP) of Cameroon and Amount of CO2 emissions(kg per 2005 US$ of GDP) of Thailand?
Provide a succinct answer. -1.12. In the year 2003, what is the difference between the Amount of CO2 emissions(kg per 2005 US$ of GDP) in Libya and Amount of CO2 emissions(kg per 2005 US$ of GDP) in Thailand?
Ensure brevity in your answer.  -0.14. In the year 2004, what is the difference between the Amount of CO2 emissions(kg per 2005 US$ of GDP) in Cameroon and Amount of CO2 emissions(kg per 2005 US$ of GDP) in Libya?
Your response must be concise. -0.95. In the year 2004, what is the difference between the Amount of CO2 emissions(kg per 2005 US$ of GDP) of Cameroon and Amount of CO2 emissions(kg per 2005 US$ of GDP) of Thailand?
Your answer should be compact. -1.14. In the year 2004, what is the difference between the Amount of CO2 emissions(kg per 2005 US$ of GDP) of Libya and Amount of CO2 emissions(kg per 2005 US$ of GDP) of Thailand?
Keep it short and to the point. -0.2. In the year 2005, what is the difference between the Amount of CO2 emissions(kg per 2005 US$ of GDP) in Cameroon and Amount of CO2 emissions(kg per 2005 US$ of GDP) in Libya?
Ensure brevity in your answer.  -0.88. In the year 2005, what is the difference between the Amount of CO2 emissions(kg per 2005 US$ of GDP) of Cameroon and Amount of CO2 emissions(kg per 2005 US$ of GDP) of Thailand?
Ensure brevity in your answer.  -1.13. In the year 2005, what is the difference between the Amount of CO2 emissions(kg per 2005 US$ of GDP) in Libya and Amount of CO2 emissions(kg per 2005 US$ of GDP) in Thailand?
Offer a terse response. -0.25. In the year 2006, what is the difference between the Amount of CO2 emissions(kg per 2005 US$ of GDP) of Cameroon and Amount of CO2 emissions(kg per 2005 US$ of GDP) of Libya?
Your answer should be compact. -0.86. In the year 2006, what is the difference between the Amount of CO2 emissions(kg per 2005 US$ of GDP) of Cameroon and Amount of CO2 emissions(kg per 2005 US$ of GDP) of Thailand?
Offer a very short reply. -1.1. In the year 2006, what is the difference between the Amount of CO2 emissions(kg per 2005 US$ of GDP) in Libya and Amount of CO2 emissions(kg per 2005 US$ of GDP) in Thailand?
Keep it short and to the point. -0.25. In the year 2007, what is the difference between the Amount of CO2 emissions(kg per 2005 US$ of GDP) of Cameroon and Amount of CO2 emissions(kg per 2005 US$ of GDP) of Libya?
Ensure brevity in your answer.  -0.66. In the year 2007, what is the difference between the Amount of CO2 emissions(kg per 2005 US$ of GDP) of Cameroon and Amount of CO2 emissions(kg per 2005 US$ of GDP) of Thailand?
Make the answer very short. -0.94. In the year 2007, what is the difference between the Amount of CO2 emissions(kg per 2005 US$ of GDP) of Libya and Amount of CO2 emissions(kg per 2005 US$ of GDP) of Thailand?
Make the answer very short. -0.27. In the year 2008, what is the difference between the Amount of CO2 emissions(kg per 2005 US$ of GDP) in Cameroon and Amount of CO2 emissions(kg per 2005 US$ of GDP) in Libya?
Offer a terse response. -0.71. In the year 2008, what is the difference between the Amount of CO2 emissions(kg per 2005 US$ of GDP) of Cameroon and Amount of CO2 emissions(kg per 2005 US$ of GDP) of Thailand?
Keep it short and to the point. -0.94. In the year 2008, what is the difference between the Amount of CO2 emissions(kg per 2005 US$ of GDP) in Libya and Amount of CO2 emissions(kg per 2005 US$ of GDP) in Thailand?
Provide a short and direct response. -0.23. In the year 2009, what is the difference between the Amount of CO2 emissions(kg per 2005 US$ of GDP) of Cameroon and Amount of CO2 emissions(kg per 2005 US$ of GDP) of Libya?
Your answer should be very brief. -0.78. In the year 2009, what is the difference between the Amount of CO2 emissions(kg per 2005 US$ of GDP) in Cameroon and Amount of CO2 emissions(kg per 2005 US$ of GDP) in Thailand?
Provide a short and direct response. -0.96. In the year 2009, what is the difference between the Amount of CO2 emissions(kg per 2005 US$ of GDP) in Libya and Amount of CO2 emissions(kg per 2005 US$ of GDP) in Thailand?
Provide a short and direct response. -0.18. What is the ratio of the Amount of CO2 emissions(kg per 2005 US$ of GDP) of Cameroon in 2002 to that in 2003?
Offer a terse response. 0.94. What is the ratio of the Amount of CO2 emissions(kg per 2005 US$ of GDP) of Libya in 2002 to that in 2003?
Provide a short and direct response. 1.1. What is the ratio of the Amount of CO2 emissions(kg per 2005 US$ of GDP) in Cameroon in 2002 to that in 2004?
Your answer should be very brief. 0.93. What is the ratio of the Amount of CO2 emissions(kg per 2005 US$ of GDP) in Libya in 2002 to that in 2004?
Give a very brief answer. 1.12. What is the ratio of the Amount of CO2 emissions(kg per 2005 US$ of GDP) in Thailand in 2002 to that in 2004?
Make the answer very short. 0.98. What is the ratio of the Amount of CO2 emissions(kg per 2005 US$ of GDP) in Cameroon in 2002 to that in 2005?
Offer a very short reply. 1.02. What is the ratio of the Amount of CO2 emissions(kg per 2005 US$ of GDP) of Libya in 2002 to that in 2005?
Provide a short and direct response. 1.21. What is the ratio of the Amount of CO2 emissions(kg per 2005 US$ of GDP) in Cameroon in 2002 to that in 2006?
Make the answer very short. 1.01. What is the ratio of the Amount of CO2 emissions(kg per 2005 US$ of GDP) of Libya in 2002 to that in 2006?
Offer a very short reply. 1.23. What is the ratio of the Amount of CO2 emissions(kg per 2005 US$ of GDP) in Thailand in 2002 to that in 2006?
Make the answer very short. 1.02. What is the ratio of the Amount of CO2 emissions(kg per 2005 US$ of GDP) in Cameroon in 2002 to that in 2007?
Ensure brevity in your answer.  0.69. What is the ratio of the Amount of CO2 emissions(kg per 2005 US$ of GDP) in Libya in 2002 to that in 2007?
Provide a succinct answer. 1.34. What is the ratio of the Amount of CO2 emissions(kg per 2005 US$ of GDP) of Thailand in 2002 to that in 2007?
Your response must be concise. 1.07. What is the ratio of the Amount of CO2 emissions(kg per 2005 US$ of GDP) of Cameroon in 2002 to that in 2008?
Make the answer very short. 0.75. What is the ratio of the Amount of CO2 emissions(kg per 2005 US$ of GDP) in Libya in 2002 to that in 2008?
Your answer should be compact. 1.31. What is the ratio of the Amount of CO2 emissions(kg per 2005 US$ of GDP) of Thailand in 2002 to that in 2008?
Offer a very short reply. 1.09. What is the ratio of the Amount of CO2 emissions(kg per 2005 US$ of GDP) of Cameroon in 2002 to that in 2009?
Offer a terse response. 0.63. What is the ratio of the Amount of CO2 emissions(kg per 2005 US$ of GDP) of Libya in 2002 to that in 2009?
Provide a short and direct response. 1.17. What is the ratio of the Amount of CO2 emissions(kg per 2005 US$ of GDP) in Thailand in 2002 to that in 2009?
Provide a succinct answer. 1.03. What is the ratio of the Amount of CO2 emissions(kg per 2005 US$ of GDP) of Libya in 2003 to that in 2004?
Provide a succinct answer. 1.02. What is the ratio of the Amount of CO2 emissions(kg per 2005 US$ of GDP) in Thailand in 2003 to that in 2004?
Offer a very short reply. 0.98. What is the ratio of the Amount of CO2 emissions(kg per 2005 US$ of GDP) of Cameroon in 2003 to that in 2005?
Provide a short and direct response. 1.09. What is the ratio of the Amount of CO2 emissions(kg per 2005 US$ of GDP) in Libya in 2003 to that in 2005?
Provide a succinct answer. 1.1. What is the ratio of the Amount of CO2 emissions(kg per 2005 US$ of GDP) of Cameroon in 2003 to that in 2006?
Give a very brief answer. 1.08. What is the ratio of the Amount of CO2 emissions(kg per 2005 US$ of GDP) in Libya in 2003 to that in 2006?
Offer a very short reply. 1.12. What is the ratio of the Amount of CO2 emissions(kg per 2005 US$ of GDP) in Thailand in 2003 to that in 2006?
Keep it short and to the point. 1.02. What is the ratio of the Amount of CO2 emissions(kg per 2005 US$ of GDP) of Cameroon in 2003 to that in 2007?
Offer a very short reply. 0.74. What is the ratio of the Amount of CO2 emissions(kg per 2005 US$ of GDP) in Libya in 2003 to that in 2007?
Offer a terse response. 1.22. What is the ratio of the Amount of CO2 emissions(kg per 2005 US$ of GDP) in Thailand in 2003 to that in 2007?
Provide a short and direct response. 1.07. What is the ratio of the Amount of CO2 emissions(kg per 2005 US$ of GDP) of Cameroon in 2003 to that in 2008?
Ensure brevity in your answer.  0.8. What is the ratio of the Amount of CO2 emissions(kg per 2005 US$ of GDP) in Libya in 2003 to that in 2008?
Give a very brief answer. 1.19. What is the ratio of the Amount of CO2 emissions(kg per 2005 US$ of GDP) in Thailand in 2003 to that in 2008?
Your response must be concise. 1.09. What is the ratio of the Amount of CO2 emissions(kg per 2005 US$ of GDP) of Cameroon in 2003 to that in 2009?
Give a very brief answer. 0.67. What is the ratio of the Amount of CO2 emissions(kg per 2005 US$ of GDP) in Libya in 2003 to that in 2009?
Provide a short and direct response. 1.06. What is the ratio of the Amount of CO2 emissions(kg per 2005 US$ of GDP) in Thailand in 2003 to that in 2009?
Your response must be concise. 1.03. What is the ratio of the Amount of CO2 emissions(kg per 2005 US$ of GDP) in Cameroon in 2004 to that in 2005?
Offer a very short reply. 1.09. What is the ratio of the Amount of CO2 emissions(kg per 2005 US$ of GDP) of Libya in 2004 to that in 2005?
Ensure brevity in your answer.  1.08. What is the ratio of the Amount of CO2 emissions(kg per 2005 US$ of GDP) of Thailand in 2004 to that in 2005?
Make the answer very short. 1.03. What is the ratio of the Amount of CO2 emissions(kg per 2005 US$ of GDP) of Cameroon in 2004 to that in 2006?
Your answer should be very brief. 1.08. What is the ratio of the Amount of CO2 emissions(kg per 2005 US$ of GDP) of Libya in 2004 to that in 2006?
Make the answer very short. 1.1. What is the ratio of the Amount of CO2 emissions(kg per 2005 US$ of GDP) in Thailand in 2004 to that in 2006?
Ensure brevity in your answer.  1.04. What is the ratio of the Amount of CO2 emissions(kg per 2005 US$ of GDP) of Cameroon in 2004 to that in 2007?
Provide a short and direct response. 0.74. What is the ratio of the Amount of CO2 emissions(kg per 2005 US$ of GDP) in Libya in 2004 to that in 2007?
Offer a terse response. 1.2. What is the ratio of the Amount of CO2 emissions(kg per 2005 US$ of GDP) of Thailand in 2004 to that in 2007?
Keep it short and to the point. 1.1. What is the ratio of the Amount of CO2 emissions(kg per 2005 US$ of GDP) of Cameroon in 2004 to that in 2008?
Provide a short and direct response. 0.8. What is the ratio of the Amount of CO2 emissions(kg per 2005 US$ of GDP) in Libya in 2004 to that in 2008?
Your answer should be very brief. 1.17. What is the ratio of the Amount of CO2 emissions(kg per 2005 US$ of GDP) in Thailand in 2004 to that in 2008?
Offer a very short reply. 1.12. What is the ratio of the Amount of CO2 emissions(kg per 2005 US$ of GDP) in Cameroon in 2004 to that in 2009?
Ensure brevity in your answer.  0.68. What is the ratio of the Amount of CO2 emissions(kg per 2005 US$ of GDP) of Libya in 2004 to that in 2009?
Your answer should be very brief. 1.04. What is the ratio of the Amount of CO2 emissions(kg per 2005 US$ of GDP) of Thailand in 2004 to that in 2009?
Make the answer very short. 1.05. What is the ratio of the Amount of CO2 emissions(kg per 2005 US$ of GDP) in Cameroon in 2005 to that in 2006?
Provide a succinct answer. 0.99. What is the ratio of the Amount of CO2 emissions(kg per 2005 US$ of GDP) in Libya in 2005 to that in 2006?
Provide a succinct answer. 1.02. What is the ratio of the Amount of CO2 emissions(kg per 2005 US$ of GDP) in Thailand in 2005 to that in 2006?
Keep it short and to the point. 1.02. What is the ratio of the Amount of CO2 emissions(kg per 2005 US$ of GDP) in Cameroon in 2005 to that in 2007?
Make the answer very short. 0.68. What is the ratio of the Amount of CO2 emissions(kg per 2005 US$ of GDP) in Libya in 2005 to that in 2007?
Make the answer very short. 1.11. What is the ratio of the Amount of CO2 emissions(kg per 2005 US$ of GDP) of Thailand in 2005 to that in 2007?
Your answer should be compact. 1.07. What is the ratio of the Amount of CO2 emissions(kg per 2005 US$ of GDP) of Cameroon in 2005 to that in 2008?
Offer a very short reply. 0.73. What is the ratio of the Amount of CO2 emissions(kg per 2005 US$ of GDP) of Libya in 2005 to that in 2008?
Ensure brevity in your answer.  1.08. What is the ratio of the Amount of CO2 emissions(kg per 2005 US$ of GDP) of Thailand in 2005 to that in 2008?
Offer a very short reply. 1.09. What is the ratio of the Amount of CO2 emissions(kg per 2005 US$ of GDP) of Cameroon in 2005 to that in 2009?
Ensure brevity in your answer.  0.62. What is the ratio of the Amount of CO2 emissions(kg per 2005 US$ of GDP) in Libya in 2005 to that in 2009?
Provide a short and direct response. 0.96. What is the ratio of the Amount of CO2 emissions(kg per 2005 US$ of GDP) of Thailand in 2005 to that in 2009?
Your answer should be compact. 1.02. What is the ratio of the Amount of CO2 emissions(kg per 2005 US$ of GDP) in Cameroon in 2006 to that in 2007?
Provide a short and direct response. 0.68. What is the ratio of the Amount of CO2 emissions(kg per 2005 US$ of GDP) of Libya in 2006 to that in 2007?
Your answer should be compact. 1.09. What is the ratio of the Amount of CO2 emissions(kg per 2005 US$ of GDP) in Thailand in 2006 to that in 2007?
Your response must be concise. 1.05. What is the ratio of the Amount of CO2 emissions(kg per 2005 US$ of GDP) in Cameroon in 2006 to that in 2008?
Offer a terse response. 0.74. What is the ratio of the Amount of CO2 emissions(kg per 2005 US$ of GDP) of Libya in 2006 to that in 2008?
Your answer should be compact. 1.06. What is the ratio of the Amount of CO2 emissions(kg per 2005 US$ of GDP) of Thailand in 2006 to that in 2008?
Give a very brief answer. 1.07. What is the ratio of the Amount of CO2 emissions(kg per 2005 US$ of GDP) in Cameroon in 2006 to that in 2009?
Your answer should be very brief. 0.63. What is the ratio of the Amount of CO2 emissions(kg per 2005 US$ of GDP) in Libya in 2006 to that in 2009?
Ensure brevity in your answer.  0.95. What is the ratio of the Amount of CO2 emissions(kg per 2005 US$ of GDP) of Thailand in 2006 to that in 2009?
Give a very brief answer. 1.01. What is the ratio of the Amount of CO2 emissions(kg per 2005 US$ of GDP) in Cameroon in 2007 to that in 2008?
Offer a terse response. 1.08. What is the ratio of the Amount of CO2 emissions(kg per 2005 US$ of GDP) in Libya in 2007 to that in 2008?
Ensure brevity in your answer.  0.98. What is the ratio of the Amount of CO2 emissions(kg per 2005 US$ of GDP) in Thailand in 2007 to that in 2008?
Make the answer very short. 1.02. What is the ratio of the Amount of CO2 emissions(kg per 2005 US$ of GDP) in Cameroon in 2007 to that in 2009?
Make the answer very short. 0.92. What is the ratio of the Amount of CO2 emissions(kg per 2005 US$ of GDP) in Libya in 2007 to that in 2009?
Provide a short and direct response. 0.87. What is the ratio of the Amount of CO2 emissions(kg per 2005 US$ of GDP) of Thailand in 2007 to that in 2009?
Provide a succinct answer. 0.96. What is the ratio of the Amount of CO2 emissions(kg per 2005 US$ of GDP) of Cameroon in 2008 to that in 2009?
Ensure brevity in your answer.  0.85. What is the ratio of the Amount of CO2 emissions(kg per 2005 US$ of GDP) in Libya in 2008 to that in 2009?
Keep it short and to the point. 0.89. What is the ratio of the Amount of CO2 emissions(kg per 2005 US$ of GDP) of Thailand in 2008 to that in 2009?
Keep it short and to the point. 0.94. What is the difference between the highest and the second highest Amount of CO2 emissions(kg per 2005 US$ of GDP) of Libya?
Your answer should be compact. 0.12. What is the difference between the highest and the second highest Amount of CO2 emissions(kg per 2005 US$ of GDP) of Thailand?
Your response must be concise. 0.03. What is the difference between the highest and the lowest Amount of CO2 emissions(kg per 2005 US$ of GDP) of Cameroon?
Offer a very short reply. 0.14. What is the difference between the highest and the lowest Amount of CO2 emissions(kg per 2005 US$ of GDP) of Libya?
Your response must be concise. 0.34. What is the difference between the highest and the lowest Amount of CO2 emissions(kg per 2005 US$ of GDP) in Thailand?
Ensure brevity in your answer.  0.15. 